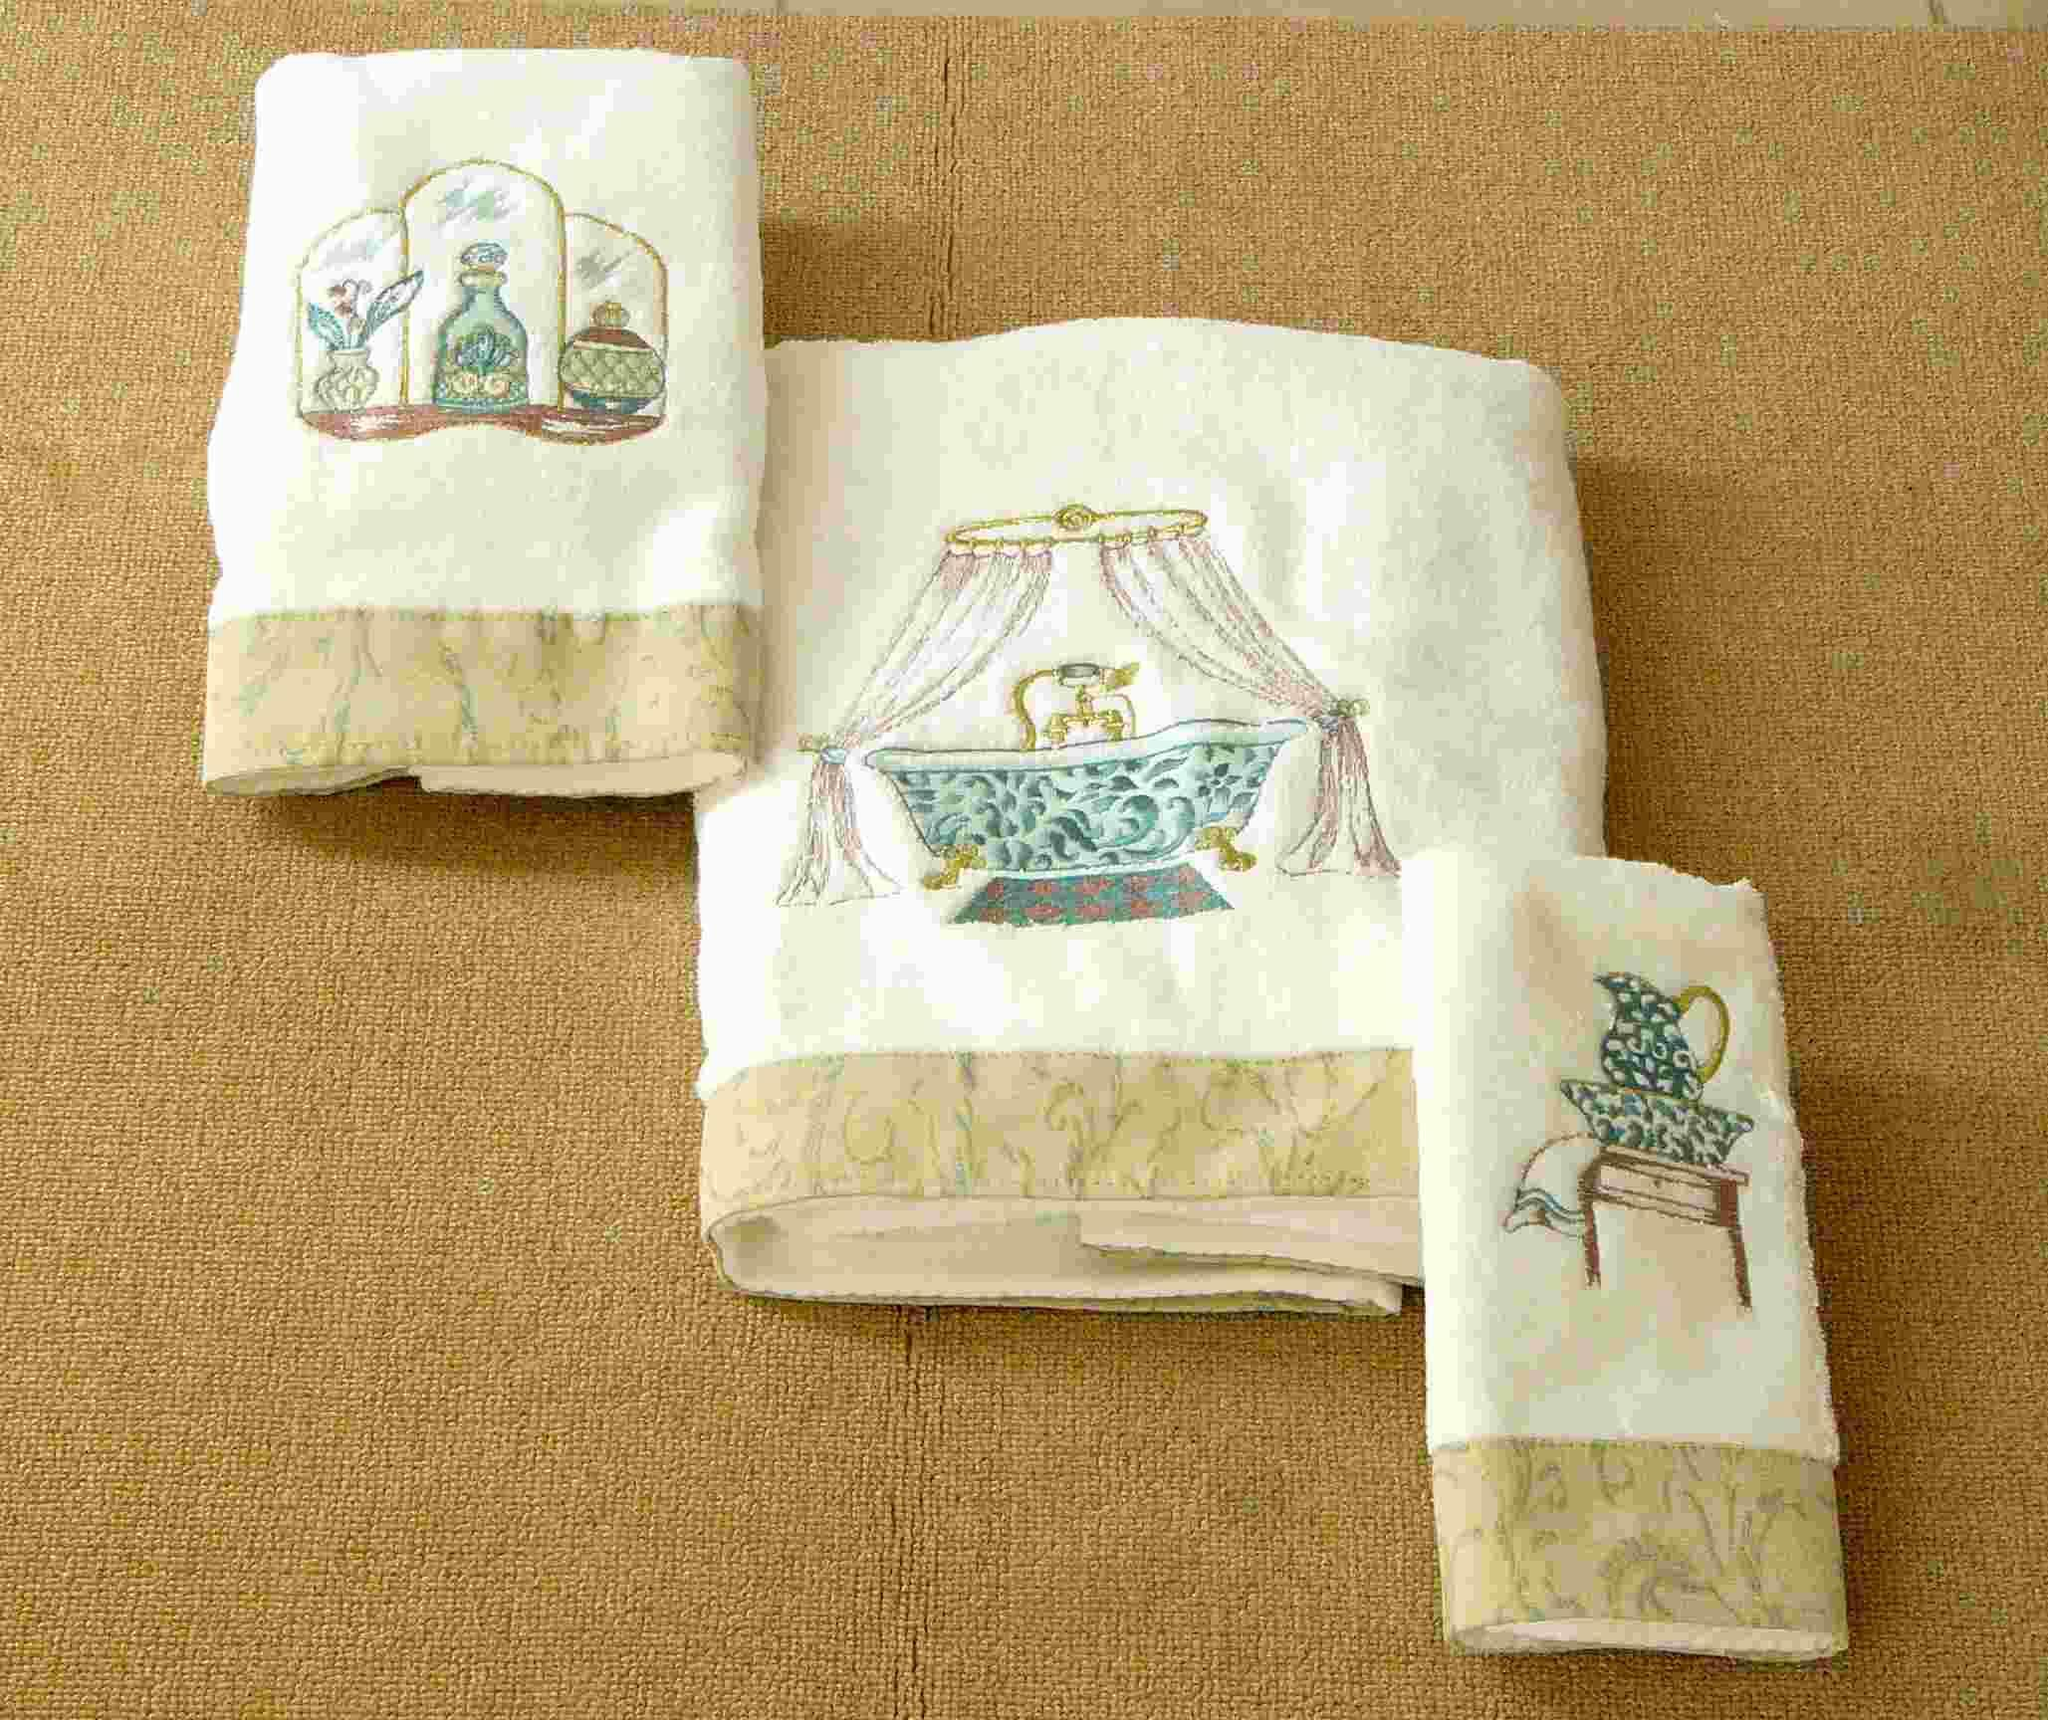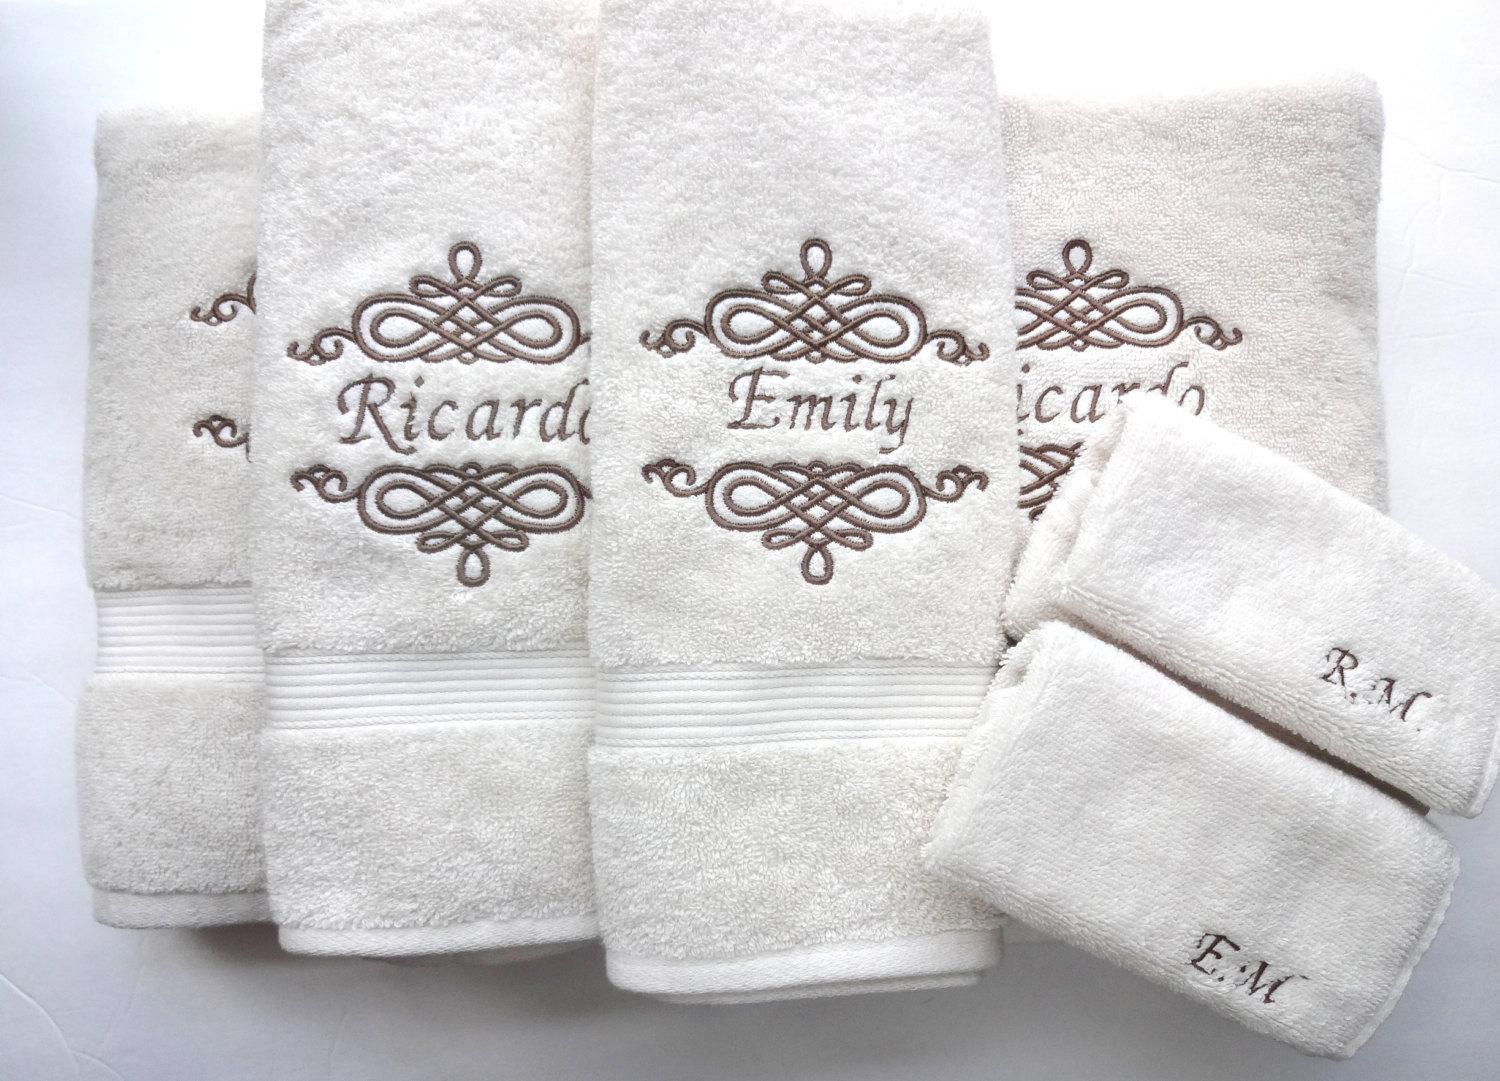The first image is the image on the left, the second image is the image on the right. Assess this claim about the two images: "Hand towels with birds on them are resting on a counter". Correct or not? Answer yes or no. No. The first image is the image on the left, the second image is the image on the right. Given the left and right images, does the statement "There are three towels with birds on them in one of the images." hold true? Answer yes or no. No. 